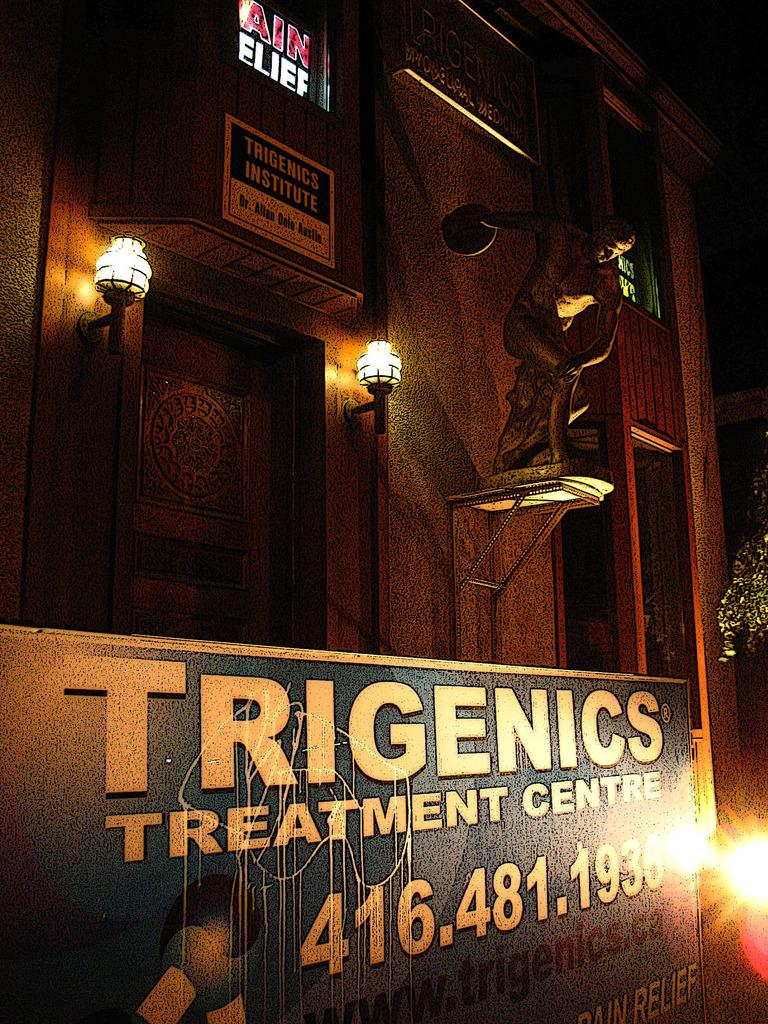What is located at the bottom of the image? There is a board at the bottom of the image. Where is the light positioned in the image? The light is on the right side of the image. What can be seen in the middle of the image? There are lights in the middle of the image, presumably for a building. Are there any insects or toads visible in the image? No, there are no insects or toads present in the image. What type of alley can be seen in the image? There is no alley present in the image. 